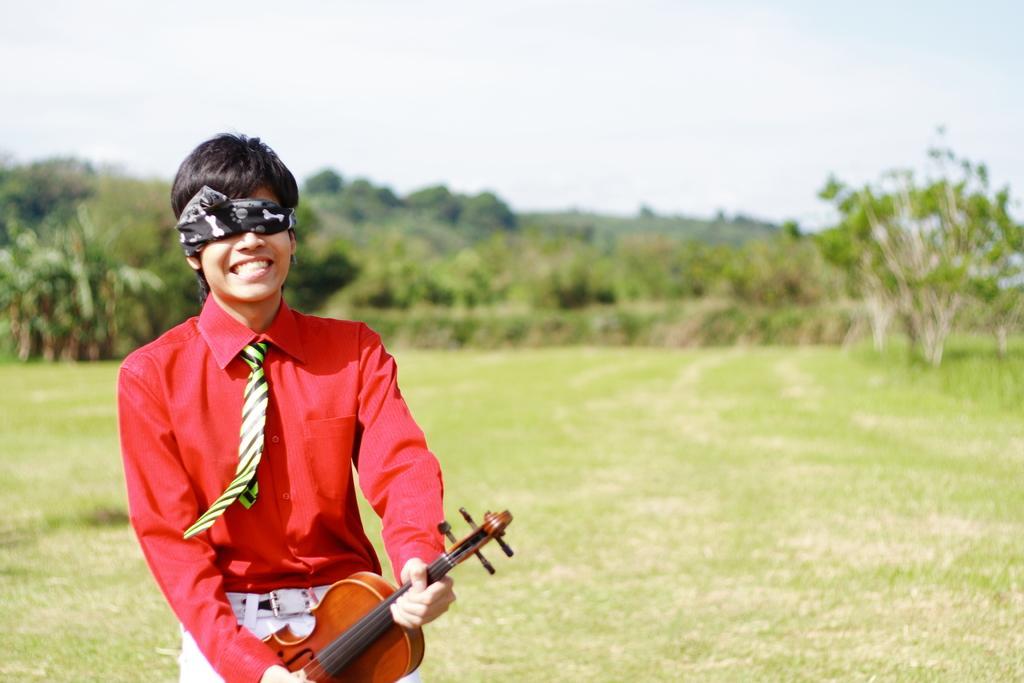Could you give a brief overview of what you see in this image? In this image I can see a man is holding a musical instrument. I can also see he has covered his eyes. In the background I can see number of trees. 